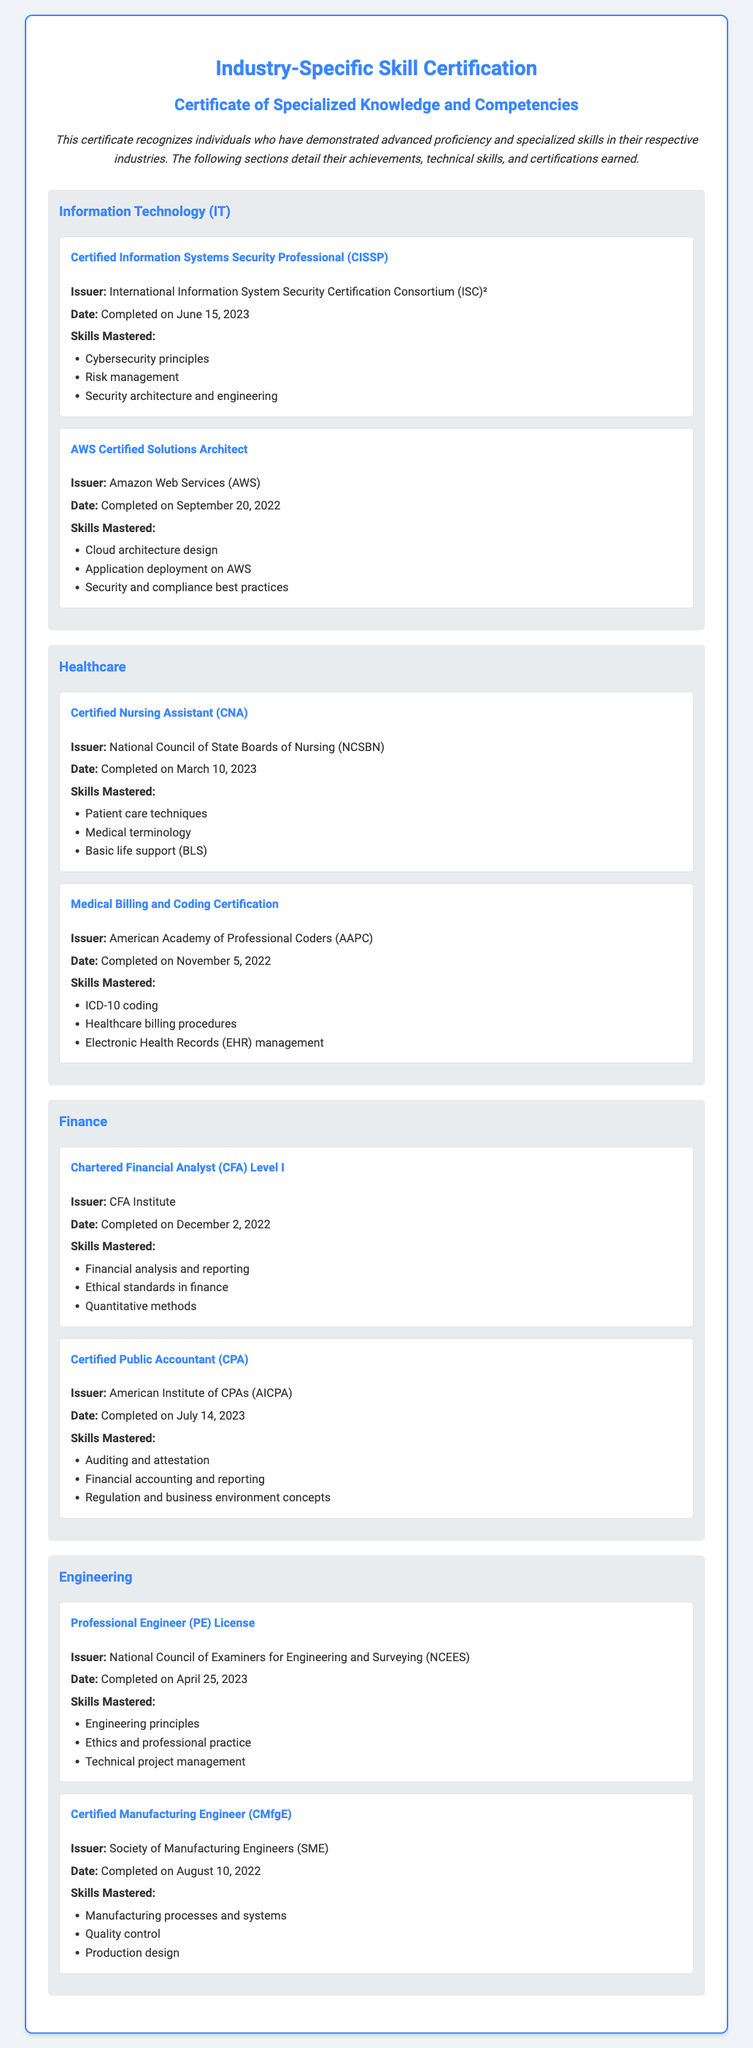What is the title of the document? The title of the document is prominently displayed at the top of the certificate.
Answer: Industry-Specific Skill Certification Who issued the Certified Information Systems Security Professional certification? The issuer of this certification is listed under the achievement details.
Answer: International Information System Security Certification Consortium (ISC)² What date was the AWS Certified Solutions Architect certification completed? The completion date is provided in the achievement section of the document.
Answer: September 20, 2022 Which skill is mastered by a Certified Nursing Assistant? The skills mastered by the CNA are listed in the respective achievement section.
Answer: Patient care techniques What are the skills mastered under the Certified Public Accountant certification? The skills mastered are listed in the achievement details under the CPA certification.
Answer: Auditing and attestation, Financial accounting and reporting, Regulation and business environment concepts How many achievements are listed under Information Technology? This involves counting the number of achievement sections for IT listed in the document.
Answer: 2 Which certification was completed on April 25, 2023? The date of completion is specifically mentioned in the achievement details.
Answer: Professional Engineer (PE) License What is the primary focus of the Engineering section of the document? This entails understanding the section's heading and achievements.
Answer: Engineering principles 